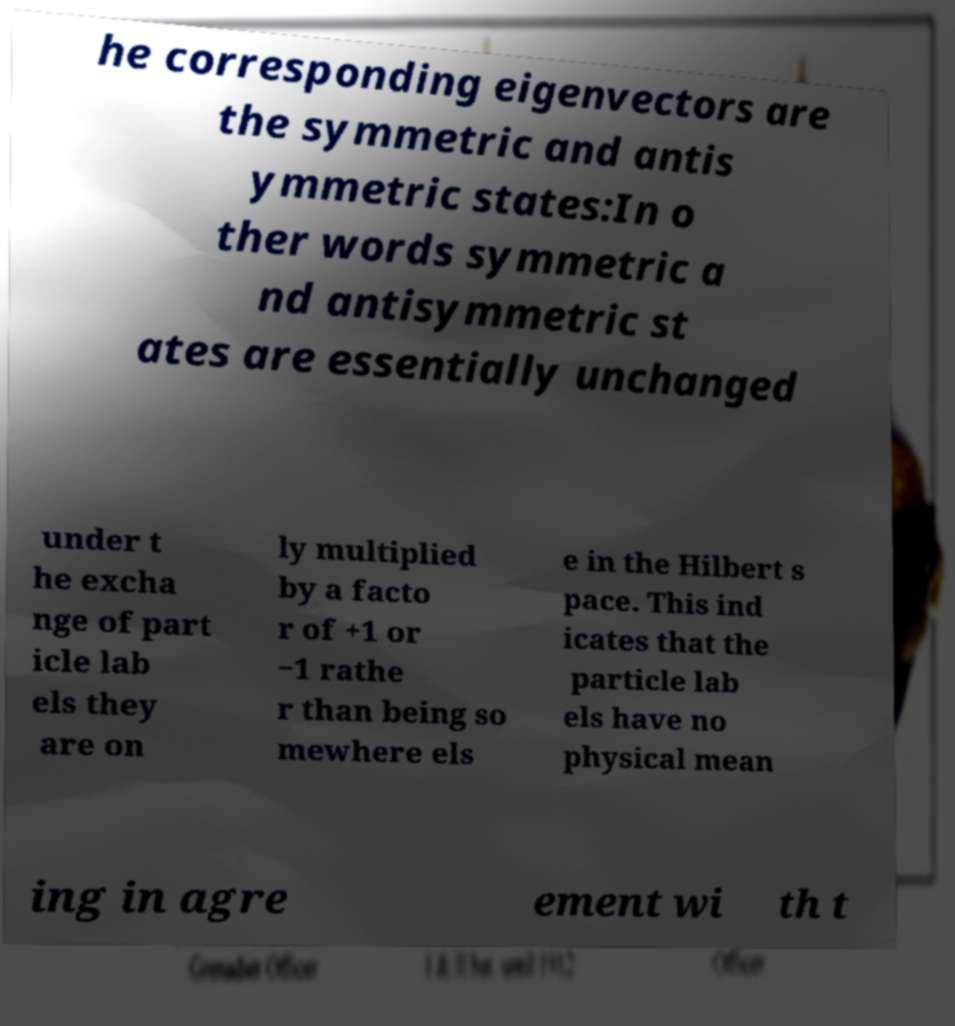Could you extract and type out the text from this image? he corresponding eigenvectors are the symmetric and antis ymmetric states:In o ther words symmetric a nd antisymmetric st ates are essentially unchanged under t he excha nge of part icle lab els they are on ly multiplied by a facto r of +1 or −1 rathe r than being so mewhere els e in the Hilbert s pace. This ind icates that the particle lab els have no physical mean ing in agre ement wi th t 